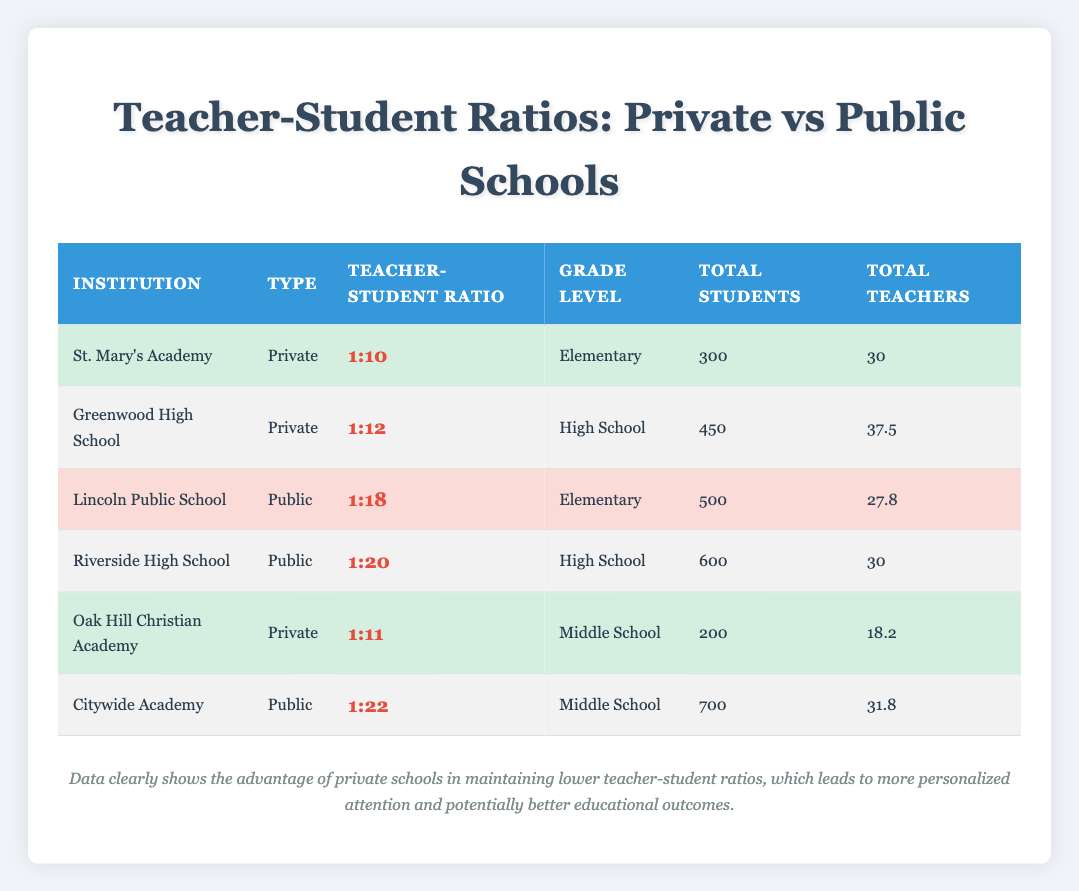What is the Teacher-Student Ratio at St. Mary’s Academy? The table shows that St. Mary's Academy, which is a private school serving elementary students, has a Teacher-Student Ratio of 10.
Answer: 10 What is the total number of teachers at Riverside High School? Looking at the entry for Riverside High School, which is a public school at the high school level, the table indicates that there are 30 total teachers.
Answer: 30 Which type of school has a higher Teacher-Student Ratio, private or public? By comparing the ratios, the highest public school ratio is 22 (Citywide Academy), while private schools have ratios that range from 10 to 12. Therefore, public schools have higher ratios overall.
Answer: Public schools What is the average Teacher-Student Ratio for private schools in the table? To find the average for private schools, we add the ratios: 10 + 12 + 11 = 33 and divide by 3: 33 / 3 = 11. The average Teacher-Student Ratio for private schools is 11.
Answer: 11 Do any private schools have more than 400 total students? St. Mary's Academy has 300 and Oak Hill Christian Academy has 200, both of which are less than 400. Greenwood High School, a private school, has 450. Therefore, yes, one private school has more than 400 students.
Answer: Yes Which private school has the most total students? The table indicates that Greenwood High School has 450 total students, the highest amongst the private institutions listed.
Answer: 450 What is the difference in Teacher-Student Ratio between the public school with the highest ratio and the private school with the highest ratio? The highest Teacher-Student Ratio for public schools is 22 (Citywide Academy) and for private schools is 12 (Greenwood High School). The difference is 22 - 12 = 10.
Answer: 10 Are there any private schools with a Teacher-Student Ratio higher than 12? The table shows that the private schools listed have ratios of 10, 11, and 12. Thus, there are no private schools with a ratio higher than 12.
Answer: No 